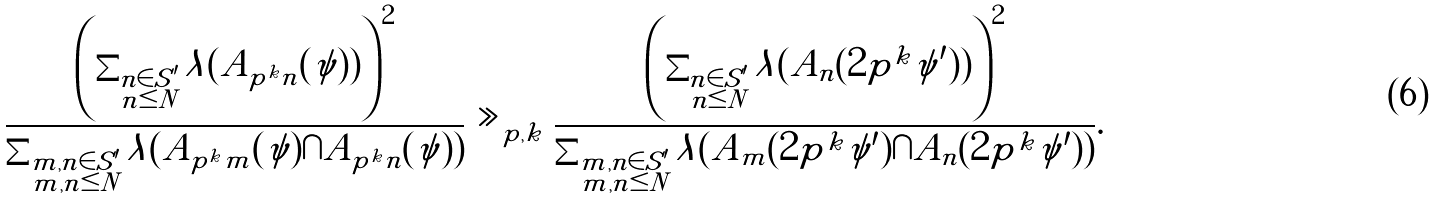Convert formula to latex. <formula><loc_0><loc_0><loc_500><loc_500>\frac { \left ( \sum _ { \substack { n \in S ^ { \prime } \\ n \leq N } } \lambda ( A _ { p ^ { k } n } ( \psi ) ) \right ) ^ { 2 } } { \sum _ { \substack { m , n \in S ^ { \prime } \\ m , n \leq N } } \lambda ( A _ { p ^ { k } m } ( \psi ) \cap A _ { p ^ { k } n } ( \psi ) ) } \gg _ { p , k } \frac { \left ( \sum _ { \substack { n \in S ^ { \prime } \\ n \leq N } } \lambda ( A _ { n } ( 2 p ^ { k } \psi ^ { \prime } ) ) \right ) ^ { 2 } } { \sum _ { \substack { m , n \in S ^ { \prime } \\ m , n \leq N } } \lambda ( A _ { m } ( 2 p ^ { k } \psi ^ { \prime } ) \cap A _ { n } ( 2 p ^ { k } \psi ^ { \prime } ) ) } .</formula> 